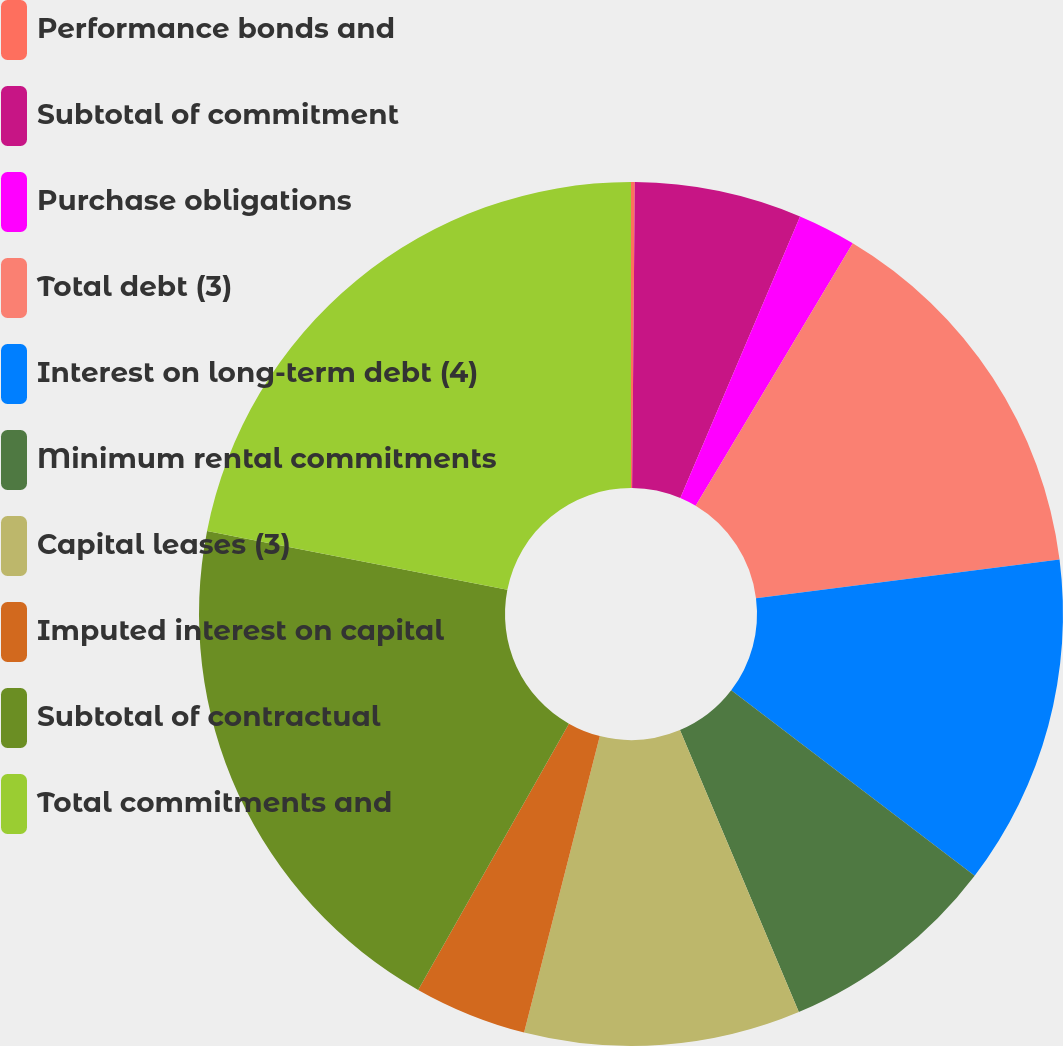Convert chart to OTSL. <chart><loc_0><loc_0><loc_500><loc_500><pie_chart><fcel>Performance bonds and<fcel>Subtotal of commitment<fcel>Purchase obligations<fcel>Total debt (3)<fcel>Interest on long-term debt (4)<fcel>Minimum rental commitments<fcel>Capital leases (3)<fcel>Imputed interest on capital<fcel>Subtotal of contractual<fcel>Total commitments and<nl><fcel>0.14%<fcel>6.26%<fcel>2.18%<fcel>14.41%<fcel>12.37%<fcel>8.29%<fcel>10.33%<fcel>4.22%<fcel>19.88%<fcel>21.92%<nl></chart> 